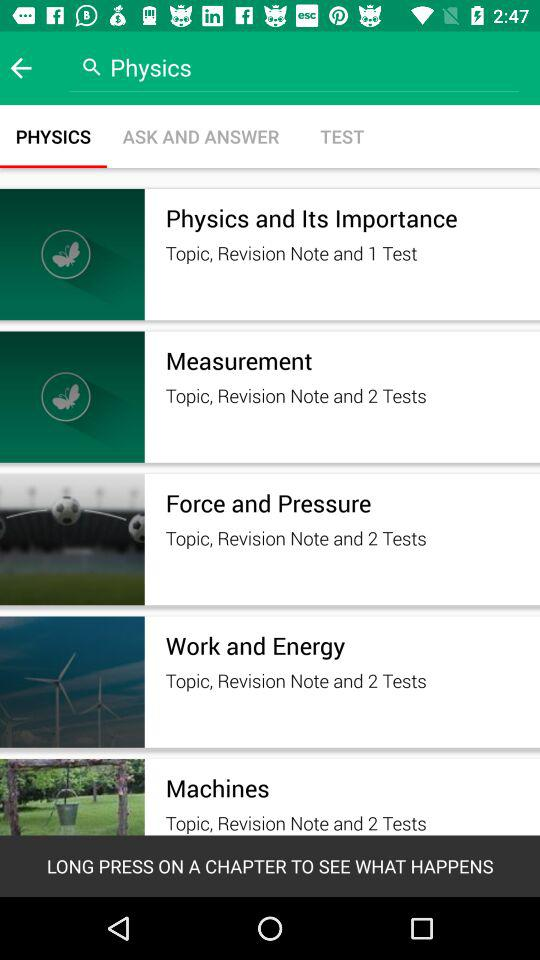Which tab is selected? The selected tab is "PHYSICS". 